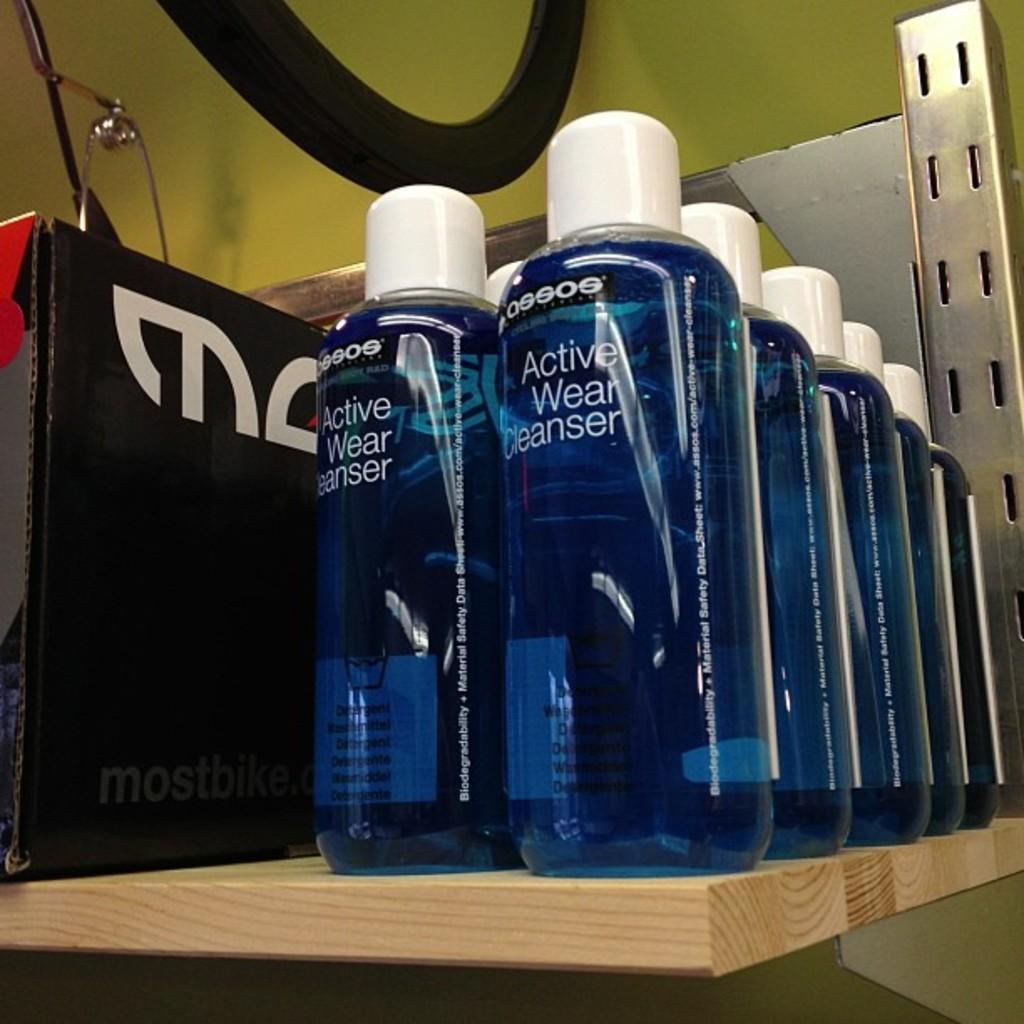<image>
Create a compact narrative representing the image presented. Two rows of bottles filled with blue Active Wear Cleanser on a shelf. 